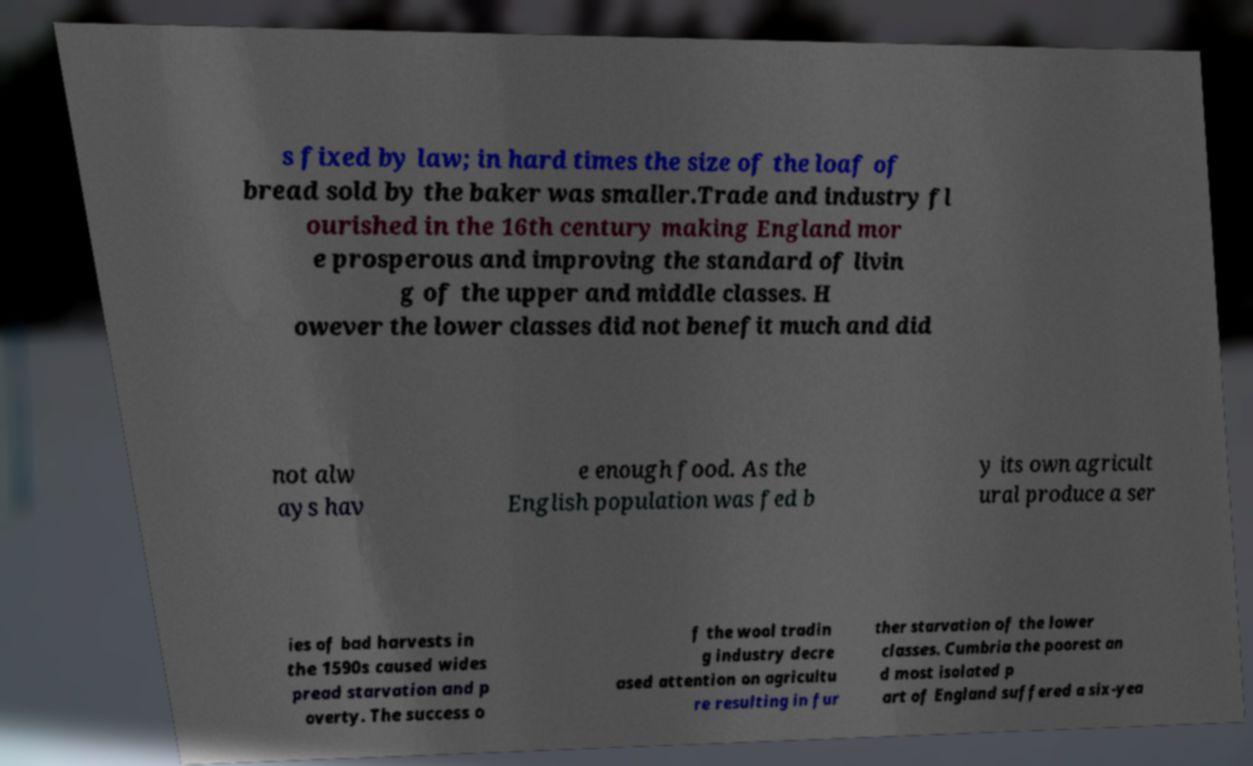For documentation purposes, I need the text within this image transcribed. Could you provide that? s fixed by law; in hard times the size of the loaf of bread sold by the baker was smaller.Trade and industry fl ourished in the 16th century making England mor e prosperous and improving the standard of livin g of the upper and middle classes. H owever the lower classes did not benefit much and did not alw ays hav e enough food. As the English population was fed b y its own agricult ural produce a ser ies of bad harvests in the 1590s caused wides pread starvation and p overty. The success o f the wool tradin g industry decre ased attention on agricultu re resulting in fur ther starvation of the lower classes. Cumbria the poorest an d most isolated p art of England suffered a six-yea 